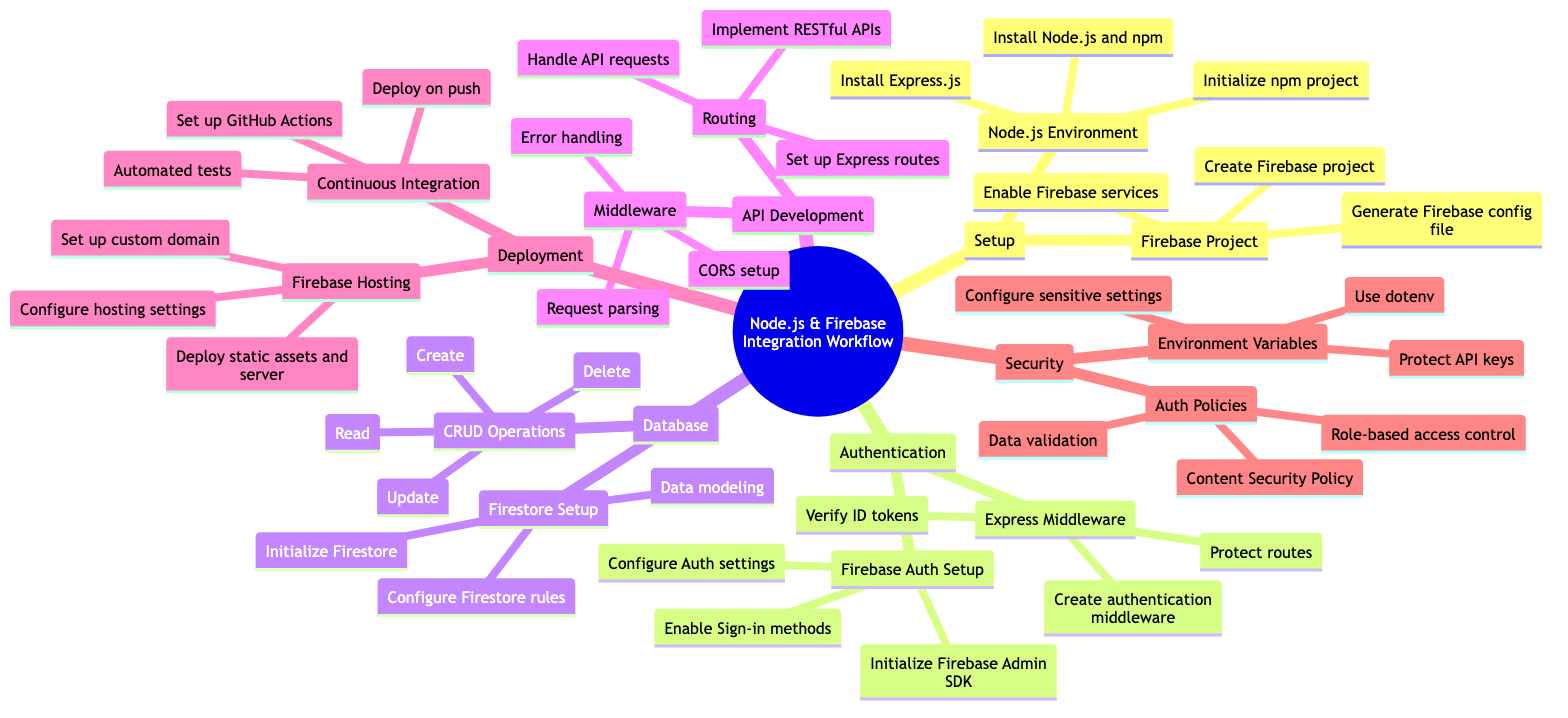What are the components of the Node.js environment setup? The Node.js environment setup includes three components: Install Node.js and npm, Initialize npm project, and Install Express.js. These components are explicitly listed in the diagram under the Node.js Environment node.
Answer: Install Node.js and npm, Initialize npm project, Install Express.js How many main sections are there in the workflow? The main sections in the workflow are Setup, Authentication, Database, API Development, Deployment, and Security. By counting these sections in the diagram, we determine that there are six main sections.
Answer: Six What is the first step in Firebase Project setup? The first step listed under Firebase Project setup is to Create Firebase project. This is the first bullet point mentioned in the Firebase Project node in the diagram.
Answer: Create Firebase project What is the purpose of the Express Middleware in the authentication section? The Express Middleware is crucial for handling aspects such as creating authentication middleware, verifying ID tokens, and protecting routes. Together, these components ensure that only authenticated users can access certain routes.
Answer: Protect routes What is included in the Continuous Integration section? The Continuous Integration section includes three components: Set up GitHub Actions, Automated tests, and Deploy on push. These components are listed under the Continuous Integration node in the Deployment area.
Answer: Set up GitHub Actions, Automated tests, Deploy on push What do Firestore rules govern? Firestore rules govern access control and data security in the Firestore database. As per the diagram, this setup under Firestore rules is essential for securing data operations within the database section.
Answer: Configure Firestore rules How many CRUD operations are mentioned in the diagram? The diagram mentions four CRUD operations: Create, Read, Update, and Delete. These operations are listed under the CRUD Operations node within the Database section, thus totaling to four.
Answer: Four What does the role-based access control policy address? The role-based access control policy addresses authentication and authorization by assigning user roles, thereby controlling what each role can access and modify, which is listed under the Auth Policies in the Security section.
Answer: Role-based access control What is the focus of the API Development section? The API Development section focuses on Routing and Middleware aspects that help set up the APIs and handle requests efficiently, aiming for smooth communication between the client and server as indicated in the diagram.
Answer: Routing and Middleware 